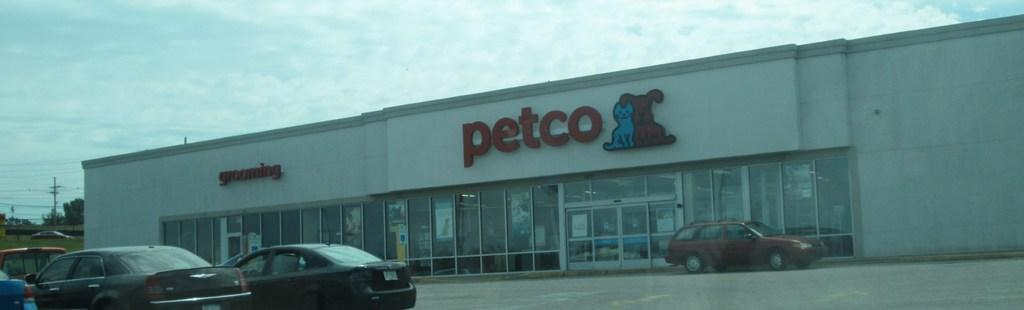What can be seen on the road in the image? There are vehicles on the road in the image. What type of structure is visible in the image? There is a building visible in the image. What are the poles used for in the image? The poles are likely used for supporting wires in the image. What is attached to the poles in the image? Wires are visible in the image, attached to the poles. What type of vegetation is present in the image? Trees are present in the image. What type of windows can be seen in the building in the image? Glass windows are visible windows are visible in the image. What is the color of the sky in the image? The sky is a combination of white and blue colors in the image. How does the grip of the stitch affect the oil production in the image? There is no mention of stitch or oil production in the image, so this question cannot be answered. 